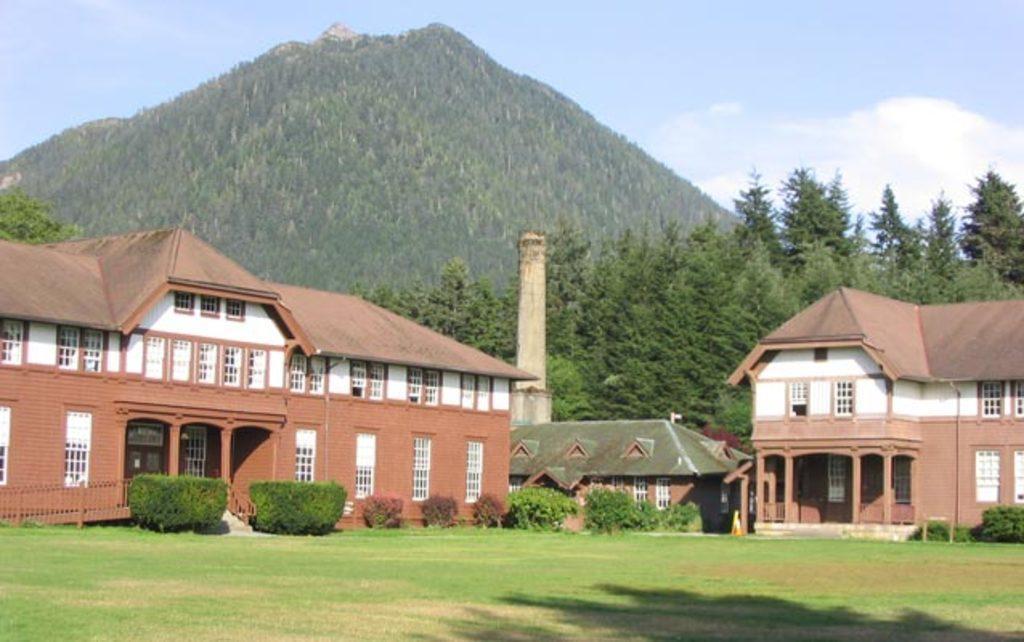Describe this image in one or two sentences. In this image we can see few buildings with doors and windows and there are some plants, trees and grass on the ground. We can see the mountains in the background and at the top we can see the sky. 